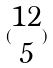Convert formula to latex. <formula><loc_0><loc_0><loc_500><loc_500>( \begin{matrix} 1 2 \\ 5 \end{matrix} )</formula> 